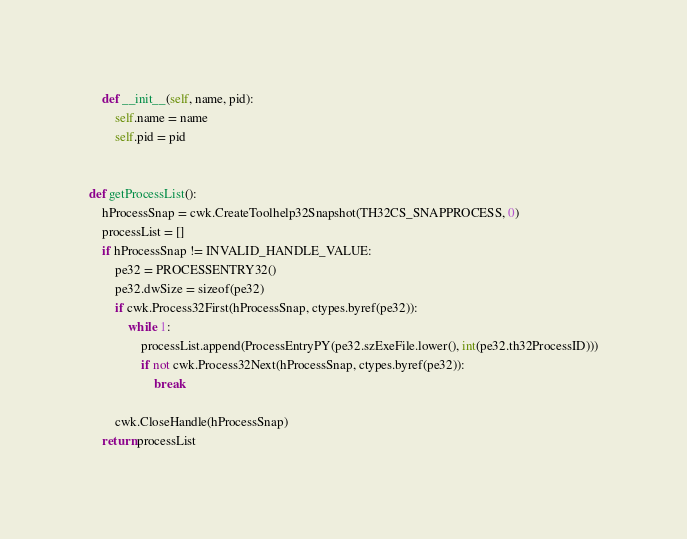Convert code to text. <code><loc_0><loc_0><loc_500><loc_500><_Python_>    def __init__(self, name, pid):
        self.name = name
        self.pid = pid


def getProcessList():
    hProcessSnap = cwk.CreateToolhelp32Snapshot(TH32CS_SNAPPROCESS, 0)
    processList = []
    if hProcessSnap != INVALID_HANDLE_VALUE:
        pe32 = PROCESSENTRY32()
        pe32.dwSize = sizeof(pe32)
        if cwk.Process32First(hProcessSnap, ctypes.byref(pe32)):
            while 1:
                processList.append(ProcessEntryPY(pe32.szExeFile.lower(), int(pe32.th32ProcessID)))
                if not cwk.Process32Next(hProcessSnap, ctypes.byref(pe32)):
                    break

        cwk.CloseHandle(hProcessSnap)
    return processList</code> 